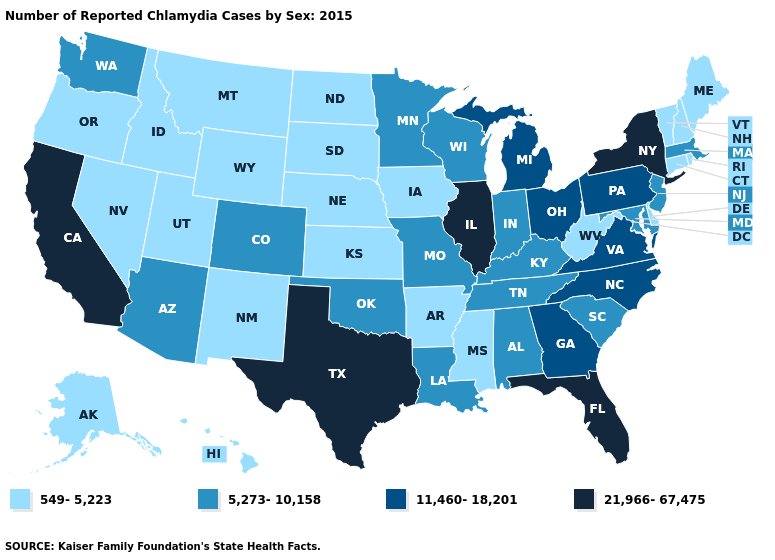What is the lowest value in states that border South Carolina?
Give a very brief answer. 11,460-18,201. Which states have the lowest value in the USA?
Give a very brief answer. Alaska, Arkansas, Connecticut, Delaware, Hawaii, Idaho, Iowa, Kansas, Maine, Mississippi, Montana, Nebraska, Nevada, New Hampshire, New Mexico, North Dakota, Oregon, Rhode Island, South Dakota, Utah, Vermont, West Virginia, Wyoming. Name the states that have a value in the range 11,460-18,201?
Keep it brief. Georgia, Michigan, North Carolina, Ohio, Pennsylvania, Virginia. Does New York have the highest value in the USA?
Concise answer only. Yes. What is the highest value in the USA?
Short answer required. 21,966-67,475. Name the states that have a value in the range 549-5,223?
Short answer required. Alaska, Arkansas, Connecticut, Delaware, Hawaii, Idaho, Iowa, Kansas, Maine, Mississippi, Montana, Nebraska, Nevada, New Hampshire, New Mexico, North Dakota, Oregon, Rhode Island, South Dakota, Utah, Vermont, West Virginia, Wyoming. What is the value of Missouri?
Answer briefly. 5,273-10,158. Does Maryland have the same value as Tennessee?
Short answer required. Yes. Does the first symbol in the legend represent the smallest category?
Be succinct. Yes. Among the states that border Missouri , does Arkansas have the highest value?
Keep it brief. No. Among the states that border North Carolina , does Virginia have the lowest value?
Quick response, please. No. What is the value of Louisiana?
Quick response, please. 5,273-10,158. What is the highest value in the USA?
Answer briefly. 21,966-67,475. Does Illinois have the lowest value in the USA?
Keep it brief. No. Which states have the lowest value in the USA?
Keep it brief. Alaska, Arkansas, Connecticut, Delaware, Hawaii, Idaho, Iowa, Kansas, Maine, Mississippi, Montana, Nebraska, Nevada, New Hampshire, New Mexico, North Dakota, Oregon, Rhode Island, South Dakota, Utah, Vermont, West Virginia, Wyoming. 